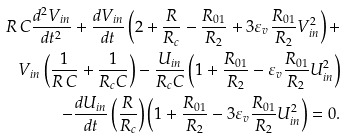Convert formula to latex. <formula><loc_0><loc_0><loc_500><loc_500>R \, C \frac { d ^ { 2 } V _ { i n } } { d t ^ { 2 } } + \frac { d V _ { i n } } { d t } \left ( 2 + \frac { R } { R _ { c } } - \frac { R _ { 0 1 } } { R _ { 2 } } + 3 \varepsilon _ { v } \frac { R _ { 0 1 } } { R _ { 2 } } V _ { i n } ^ { 2 } \right ) + \\ V _ { i n } \left ( \frac { 1 } { R \, C } + \frac { 1 } { R _ { c } C } \right ) - \frac { U _ { i n } } { R _ { c } C } \left ( 1 + \frac { R _ { 0 1 } } { R _ { 2 } } - \varepsilon _ { v } \frac { R _ { 0 1 } } { R _ { 2 } } U _ { i n } ^ { 2 } \right ) \\ - \frac { d U _ { i n } } { d t } \left ( \frac { R } { R _ { c } } \right ) \left ( 1 + \frac { R _ { 0 1 } } { R _ { 2 } } - 3 \varepsilon _ { v } \frac { R _ { 0 1 } } { R _ { 2 } } U _ { i n } ^ { 2 } \right ) = 0 .</formula> 